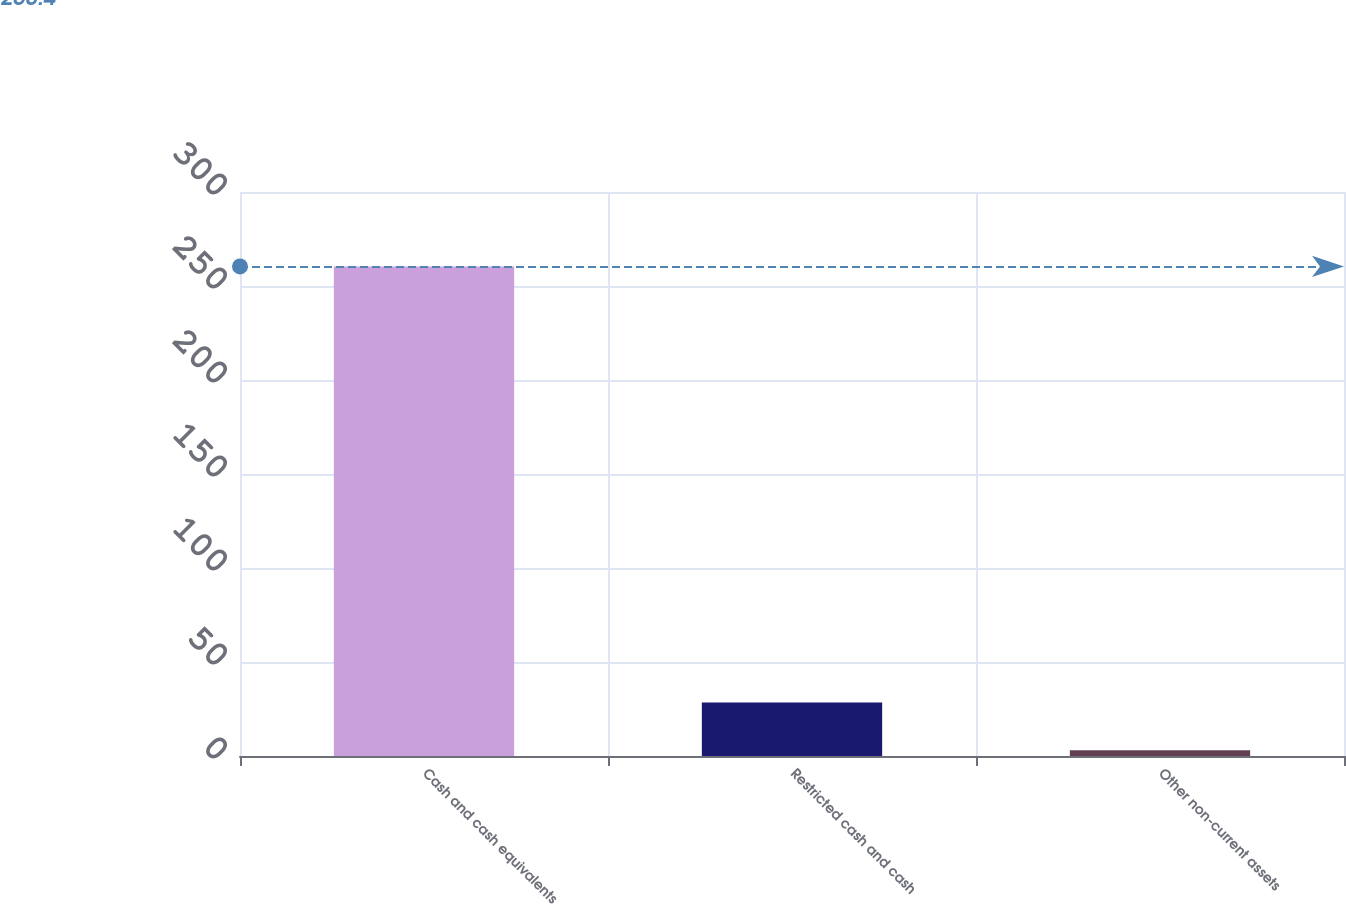Convert chart to OTSL. <chart><loc_0><loc_0><loc_500><loc_500><bar_chart><fcel>Cash and cash equivalents<fcel>Restricted cash and cash<fcel>Other non-current assets<nl><fcel>260.4<fcel>28.4<fcel>3<nl></chart> 